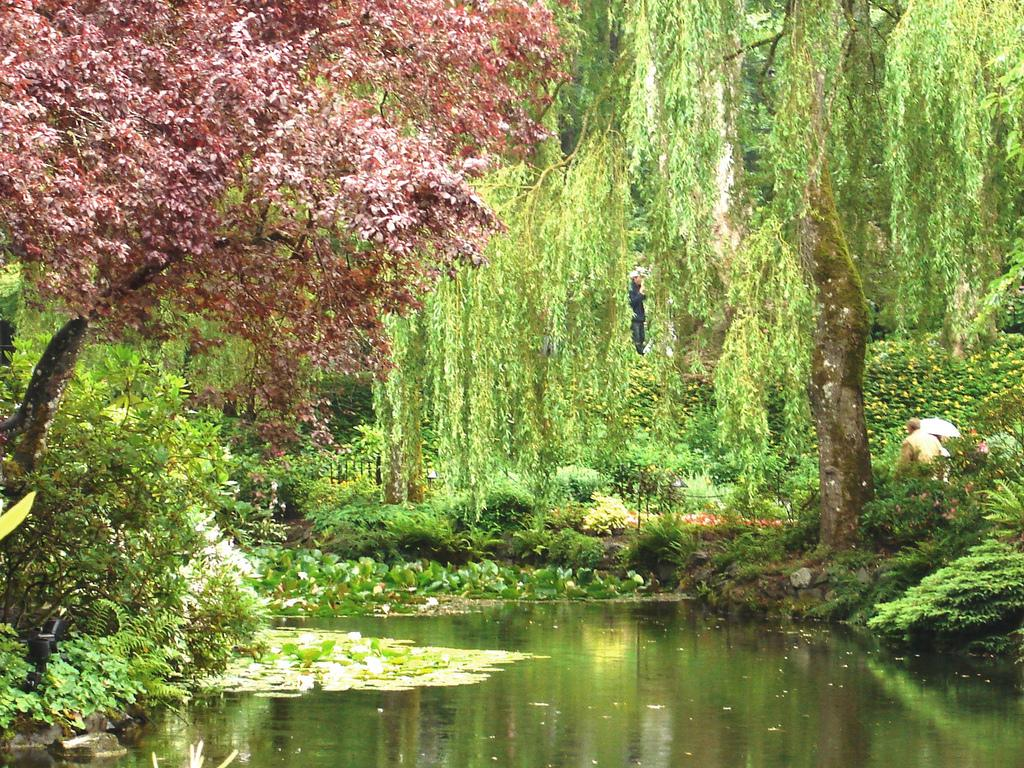What type of vegetation can be seen in the image? There are trees, grass, and plants visible in the image. What natural element is present in the image? Water is visible in the image. What type of badge is being worn by the women in the image? There are no women present in the image, and therefore no badges can be observed. 